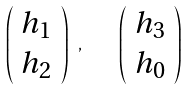<formula> <loc_0><loc_0><loc_500><loc_500>\left ( \begin{array} { c } h _ { 1 } \\ h _ { 2 } \end{array} \right ) \ , \quad \left ( \begin{array} { c } h _ { 3 } \\ h _ { 0 } \end{array} \right ) \</formula> 